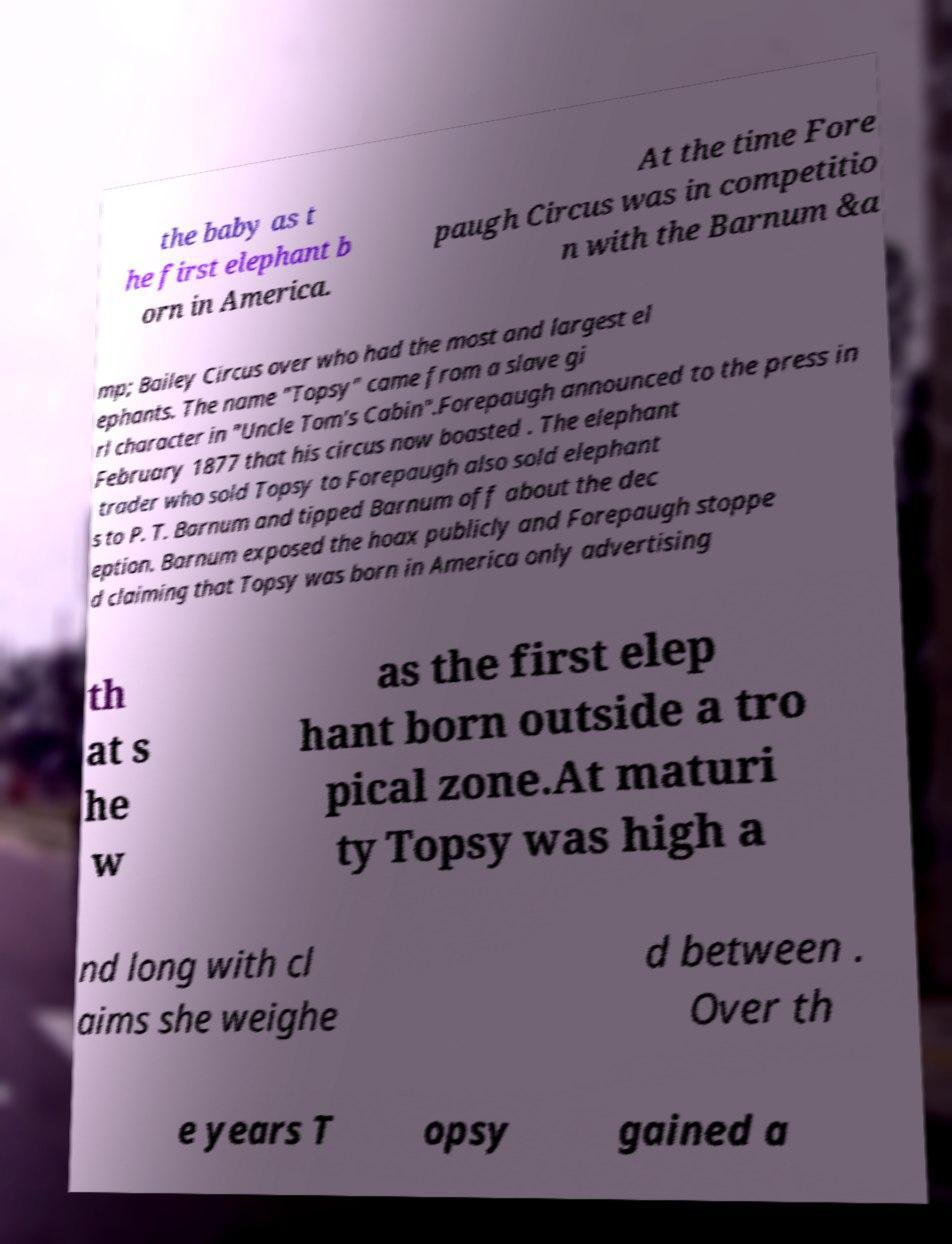Could you extract and type out the text from this image? the baby as t he first elephant b orn in America. At the time Fore paugh Circus was in competitio n with the Barnum &a mp; Bailey Circus over who had the most and largest el ephants. The name "Topsy" came from a slave gi rl character in "Uncle Tom's Cabin".Forepaugh announced to the press in February 1877 that his circus now boasted . The elephant trader who sold Topsy to Forepaugh also sold elephant s to P. T. Barnum and tipped Barnum off about the dec eption. Barnum exposed the hoax publicly and Forepaugh stoppe d claiming that Topsy was born in America only advertising th at s he w as the first elep hant born outside a tro pical zone.At maturi ty Topsy was high a nd long with cl aims she weighe d between . Over th e years T opsy gained a 